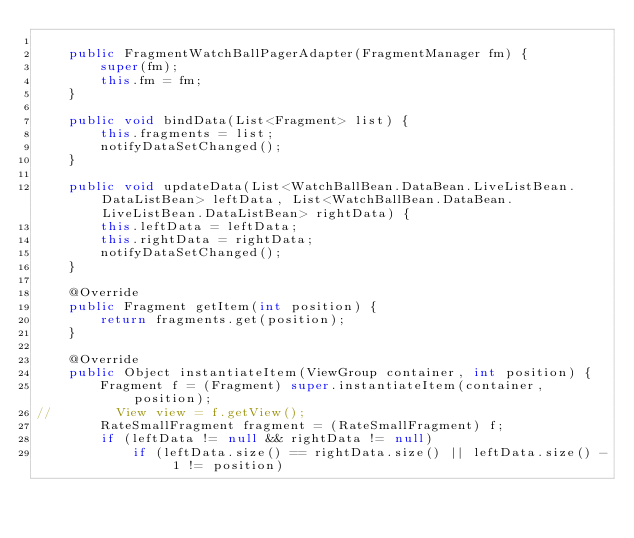<code> <loc_0><loc_0><loc_500><loc_500><_Java_>
    public FragmentWatchBallPagerAdapter(FragmentManager fm) {
        super(fm);
        this.fm = fm;
    }

    public void bindData(List<Fragment> list) {
        this.fragments = list;
        notifyDataSetChanged();
    }

    public void updateData(List<WatchBallBean.DataBean.LiveListBean.DataListBean> leftData, List<WatchBallBean.DataBean.LiveListBean.DataListBean> rightData) {
        this.leftData = leftData;
        this.rightData = rightData;
        notifyDataSetChanged();
    }

    @Override
    public Fragment getItem(int position) {
        return fragments.get(position);
    }

    @Override
    public Object instantiateItem(ViewGroup container, int position) {
        Fragment f = (Fragment) super.instantiateItem(container, position);
//        View view = f.getView();
        RateSmallFragment fragment = (RateSmallFragment) f;
        if (leftData != null && rightData != null)
            if (leftData.size() == rightData.size() || leftData.size() - 1 != position)</code> 